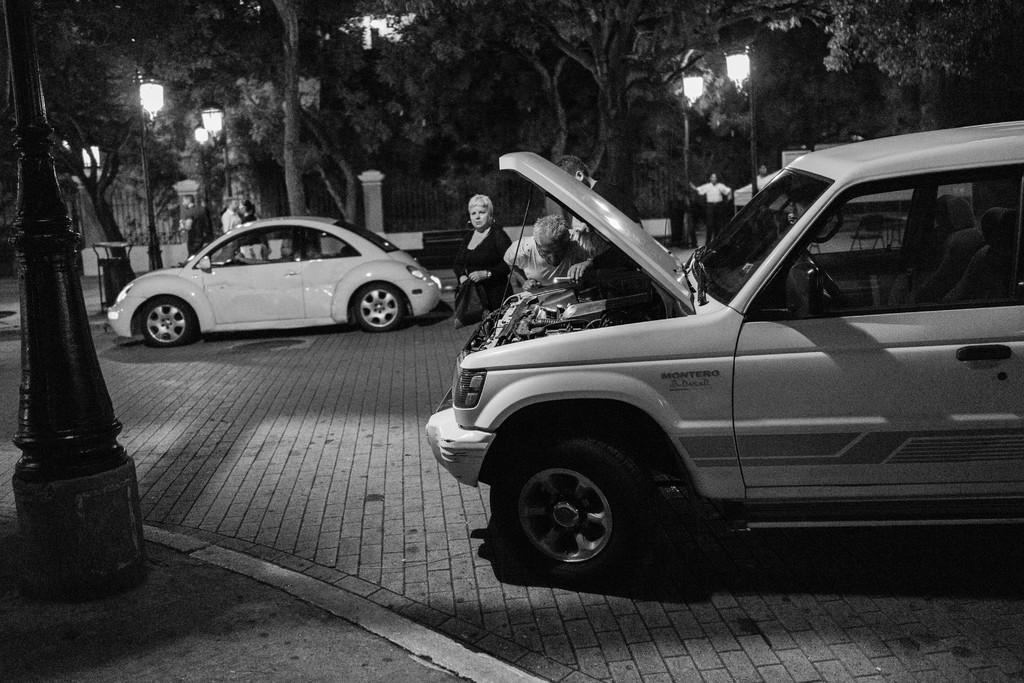What is the color scheme of the image? The image is black and white. What can be seen on the road in the image? There are two cars parked on the road in the image. Are there any people visible in the image? Yes, there are people visible in the image. What type of natural elements can be seen in the image? There are many trees in the image. What artificial elements can be seen in the image? There are light poles in the image. What type of seed is being planted by the people in the image? There is no seed being planted in the image; the people are not engaged in any gardening activity. Can you tell me how many marbles are visible on the ground in the image? There are no marbles visible on the ground in the image. 